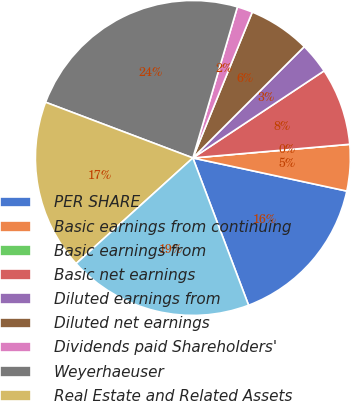Convert chart to OTSL. <chart><loc_0><loc_0><loc_500><loc_500><pie_chart><fcel>PER SHARE<fcel>Basic earnings from continuing<fcel>Basic earnings from<fcel>Basic net earnings<fcel>Diluted earnings from<fcel>Diluted net earnings<fcel>Dividends paid Shareholders'<fcel>Weyerhaeuser<fcel>Real Estate and Related Assets<fcel>Long-term debt<nl><fcel>15.87%<fcel>4.76%<fcel>0.0%<fcel>7.94%<fcel>3.17%<fcel>6.35%<fcel>1.59%<fcel>23.81%<fcel>17.46%<fcel>19.05%<nl></chart> 